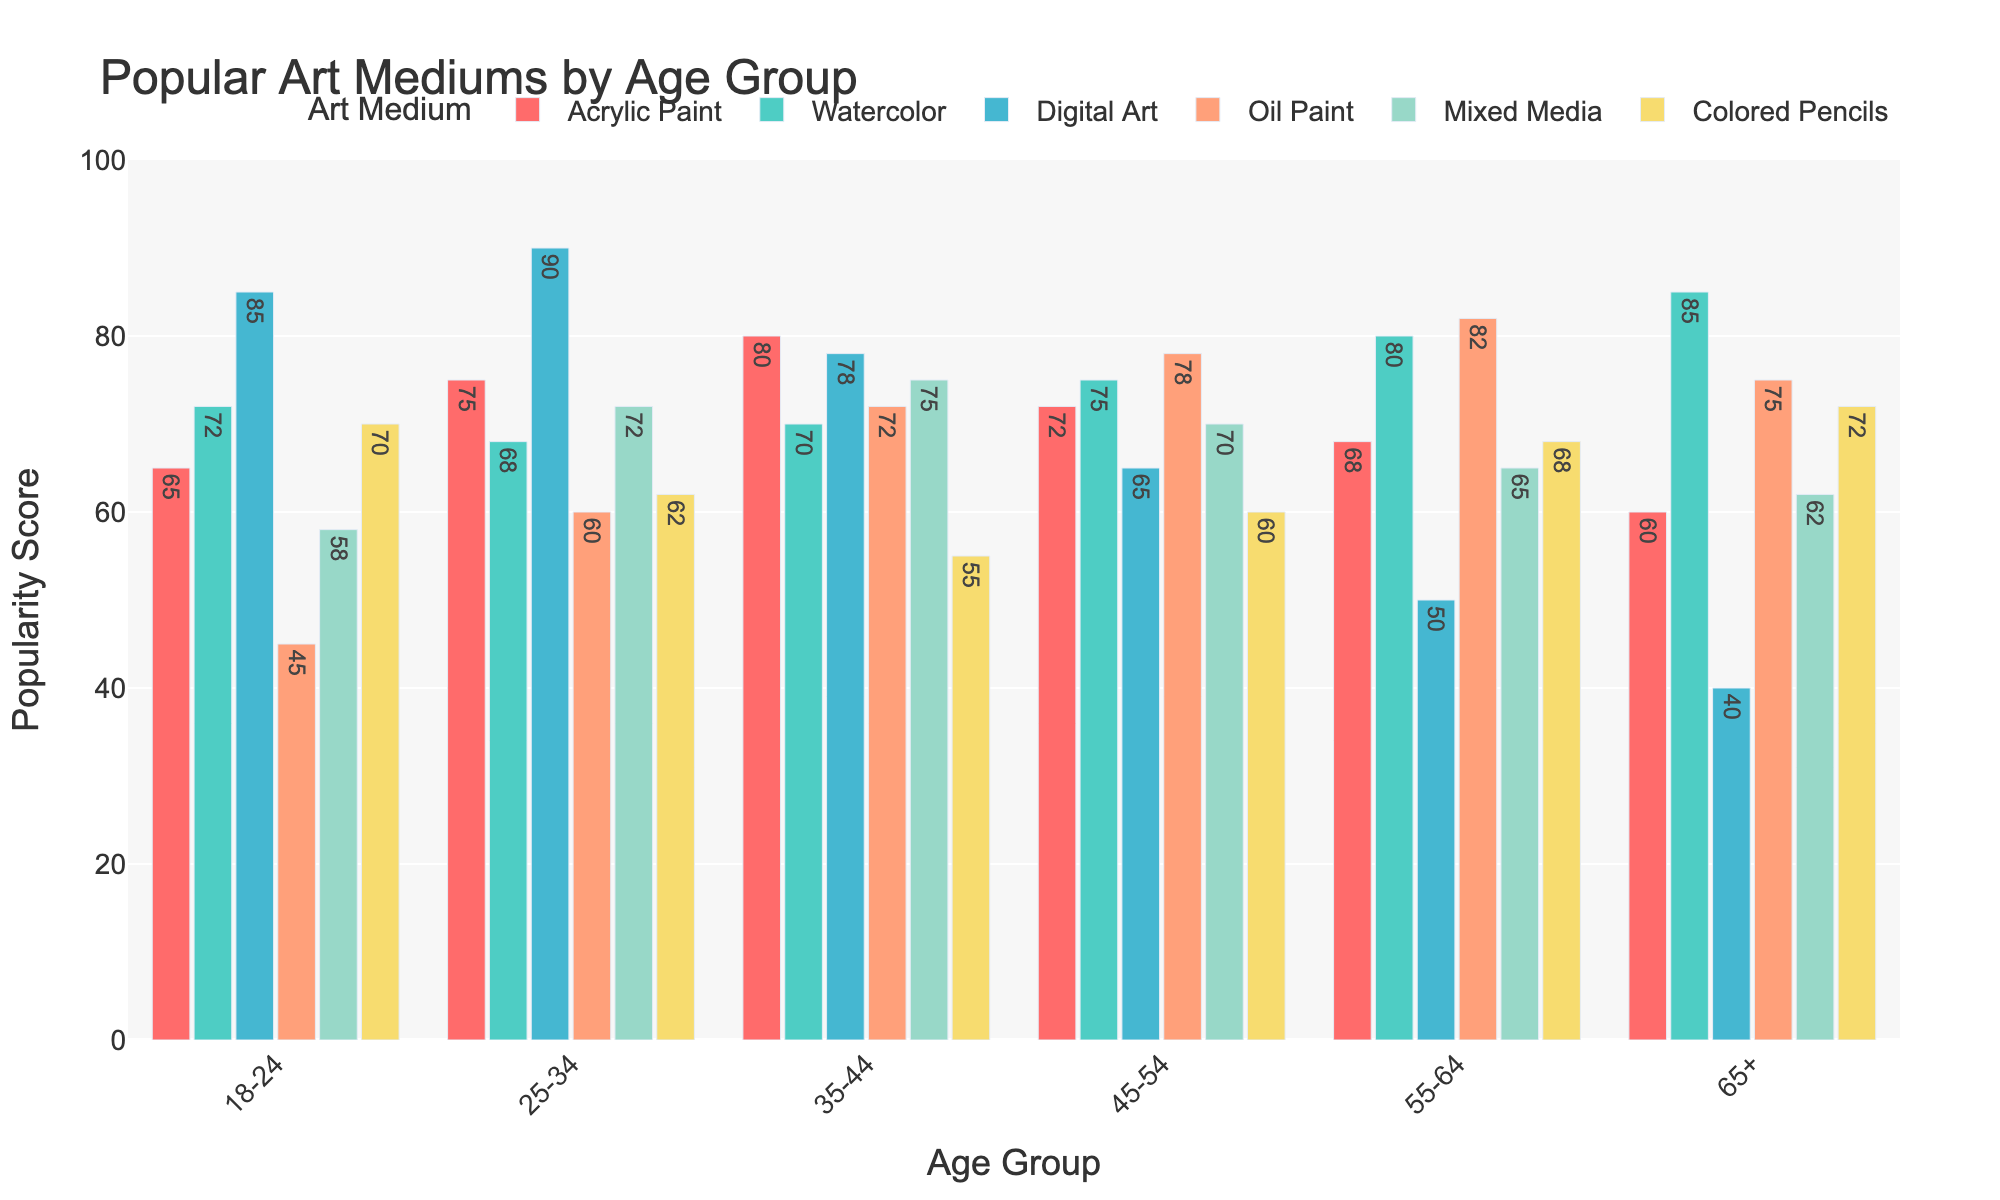Which age group uses Digital Art the most? First, locate Digital Art in the legend to identify the corresponding color for the bars (light blue). Next, compare the heights of these bars across all age groups. The tallest bar for Digital Art is in the 25-34 age group.
Answer: 25-34 Is Acrylic Paint more popular among the 35-44 age group or the 18-24 age group? Locate the bars for Acrylic Paint, identified by their red color. Compare the height of the bars between the 35-44 and 18-24 age groups. The Acrylic Paint bar is taller for the 35-44 age group at 80 compared to 65 for the 18-24 group.
Answer: 35-44 What is the average popularity score for Watercolor across all age groups? First, collect the Watercolor values across all age groups (72, 68, 70, 75, 80, 85). Sum these values to get 450. Since there are 6 values, divide the sum by 6.
Answer: 75 Which art medium shows a declining trend as age increases? Examine the bars for each medium across increasing age groups to identify any declining trends. Digital Art shows a decreasing trend with values of 85, 90, 78, 65, 50, and 40 as age increases.
Answer: Digital Art For the age group 45-54, which two art mediums are equally popular? Identify the bars for the 45-54 age group, and note their heights. Both Watercolor and Mixed Media share the same height at 75.
Answer: Watercolor and Mixed Media Is Mixed Media's popularity higher among the age group 55-64 compared to 25-34? Locate the bars for Mixed Media, represented by the bar color corresponding to Mixed Media. Compare the heights between the two age groups. The bar for 55-64 stands at 65, and for 25-34, at 72, showing it is lower for 55-64.
Answer: No Compare the difference in popularity of Oil Paint between the age groups 18-24 and 55-64. Locate the bars for Oil Paint and note their heights for both age groups. For 18-24, it is 45, and for 55-64, it is 82. The difference is 82 - 45.
Answer: 37 What is the combined popularity score of Colored Pencils for age groups 25-34 and 65+? Identify the bars for Colored Pencils in both age groups. For 25-34, it is 62, and for 65+, it is 72. The sum of these values is 62 + 72.
Answer: 134 In which age group is Watercolor more popular than Colored Pencils by the largest margin? Compare the difference in heights of bars representing Watercolor and Colored Pencils for each age group. The age group 55-64 has the largest margin with Watercolor at 80 and Colored Pencils at 68, a difference of 12.
Answer: 55-64 